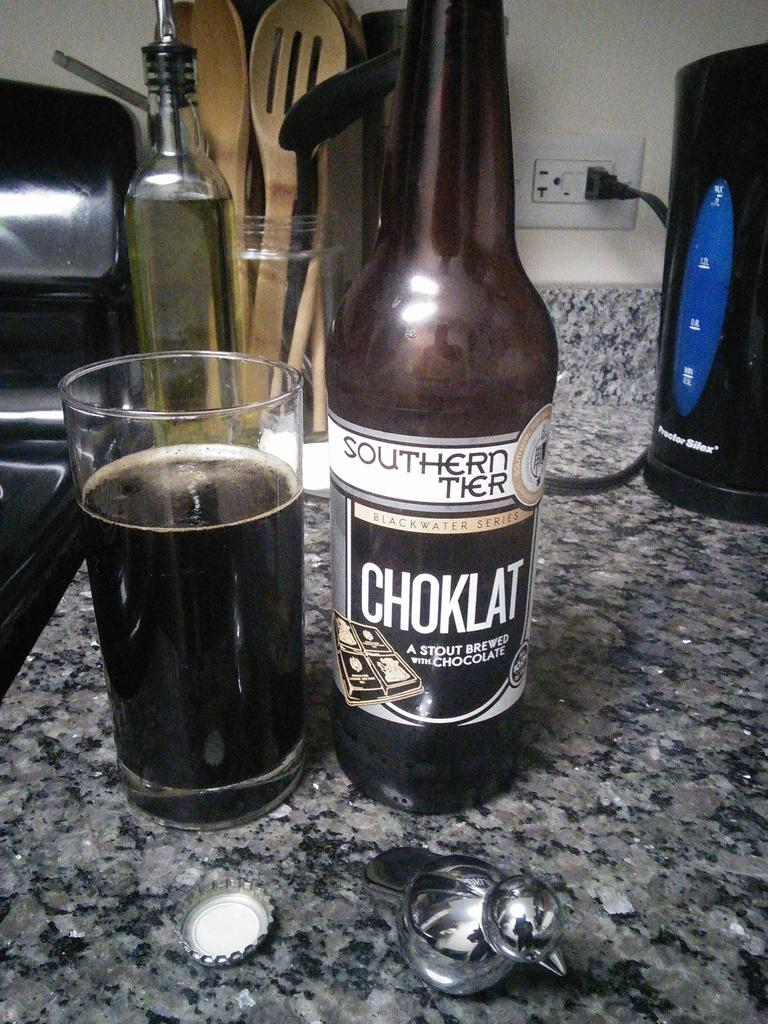<image>
Write a terse but informative summary of the picture. A bottle of Southern Tier Choklat next to a glass of beer 